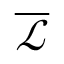<formula> <loc_0><loc_0><loc_500><loc_500>\overline { { \mathcal { L } } }</formula> 